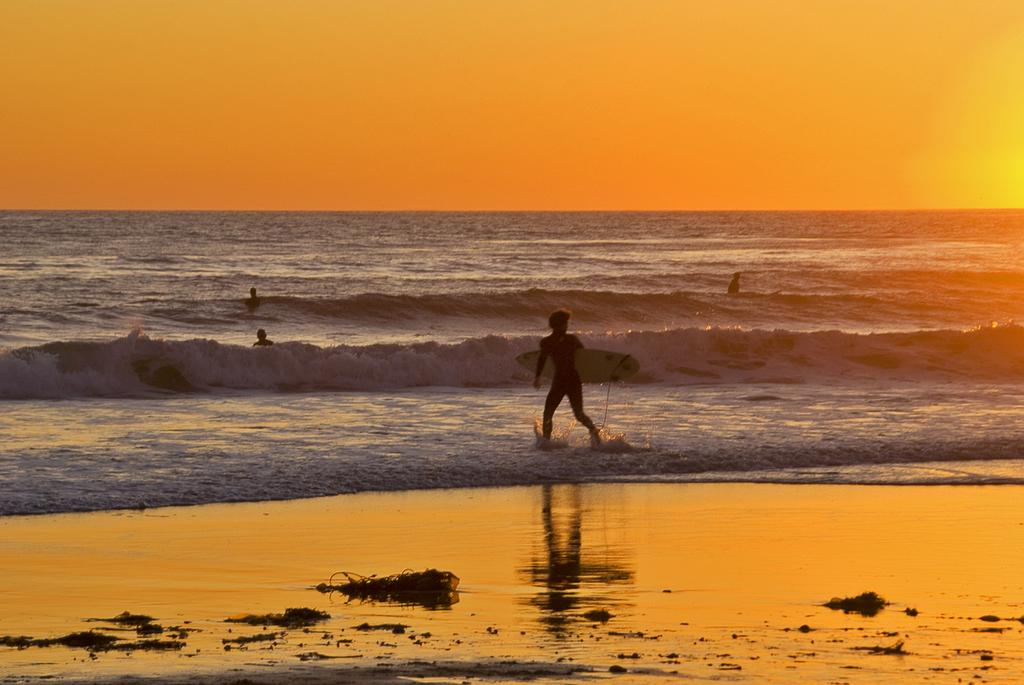What is the main setting of the image? There is a sea in the image. What are the people in the image doing? The people are in the sea. Can you describe the person near the sea shore? A person holding a ski board is visible in front of the sea shore. What is visible at the top of the image? The sky is visible at the top of the image. What type of cannon can be seen on the sea shore in the image? There is no cannon present on the sea shore in the image. Can you tell me how many people are talking to each other in the image? The image does not show people talking to each other, so it cannot be determined from the image. 